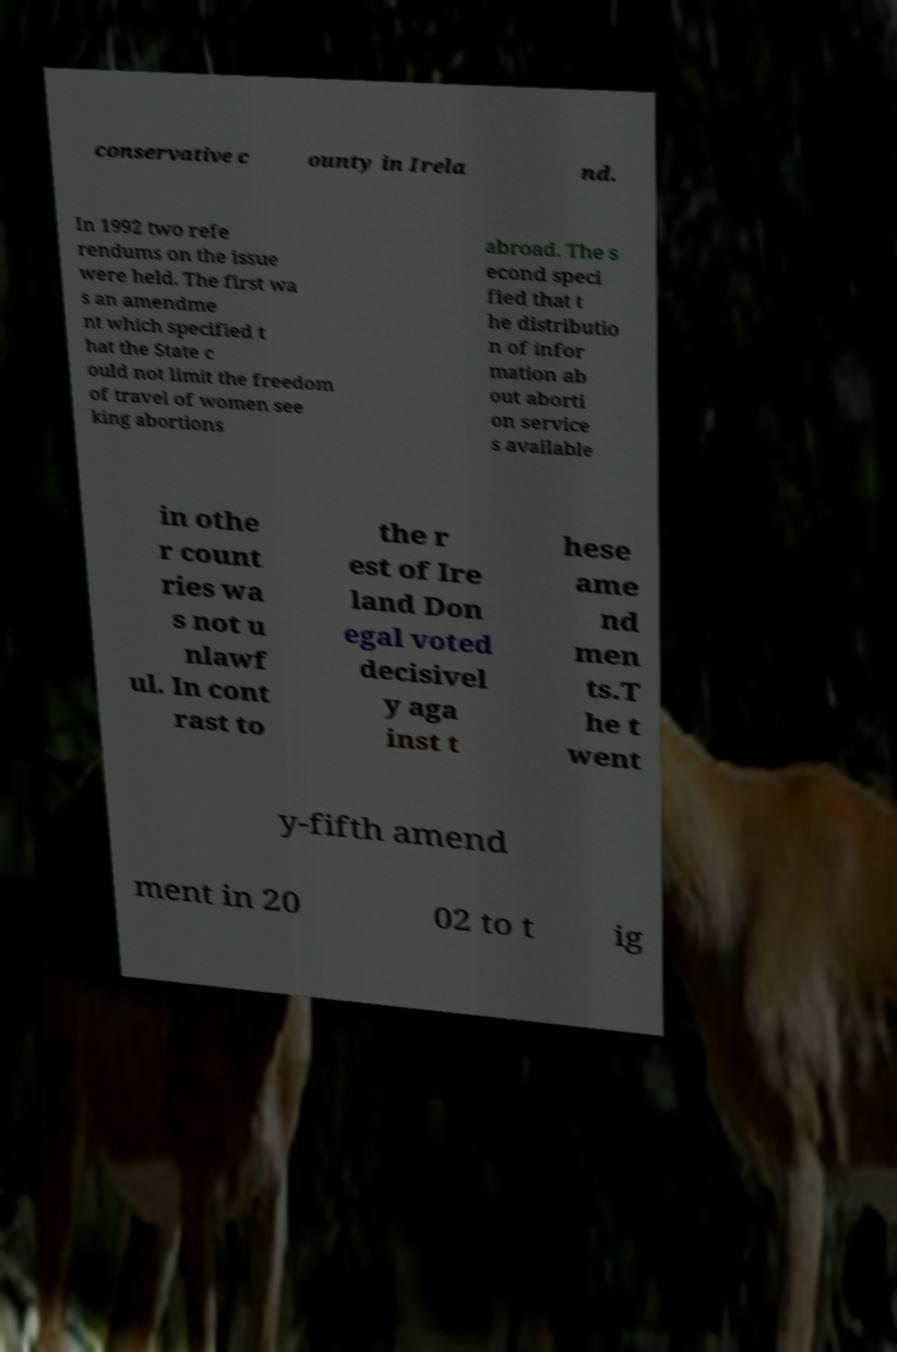Could you assist in decoding the text presented in this image and type it out clearly? conservative c ounty in Irela nd. In 1992 two refe rendums on the issue were held. The first wa s an amendme nt which specified t hat the State c ould not limit the freedom of travel of women see king abortions abroad. The s econd speci fied that t he distributio n of infor mation ab out aborti on service s available in othe r count ries wa s not u nlawf ul. In cont rast to the r est of Ire land Don egal voted decisivel y aga inst t hese ame nd men ts.T he t went y-fifth amend ment in 20 02 to t ig 